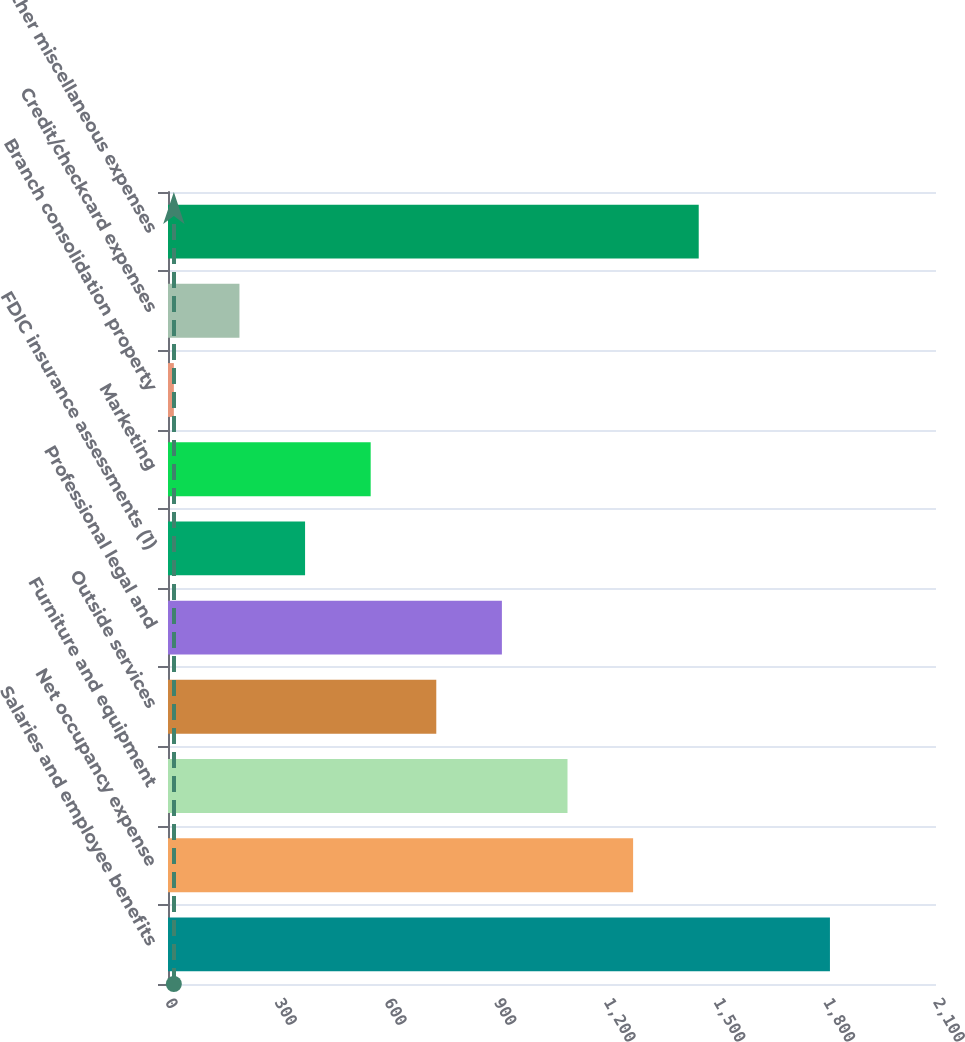<chart> <loc_0><loc_0><loc_500><loc_500><bar_chart><fcel>Salaries and employee benefits<fcel>Net occupancy expense<fcel>Furniture and equipment<fcel>Outside services<fcel>Professional legal and<fcel>FDIC insurance assessments (1)<fcel>Marketing<fcel>Branch consolidation property<fcel>Credit/checkcard expenses<fcel>Other miscellaneous expenses<nl><fcel>1810<fcel>1271.8<fcel>1092.4<fcel>733.6<fcel>913<fcel>374.8<fcel>554.2<fcel>16<fcel>195.4<fcel>1451.2<nl></chart> 